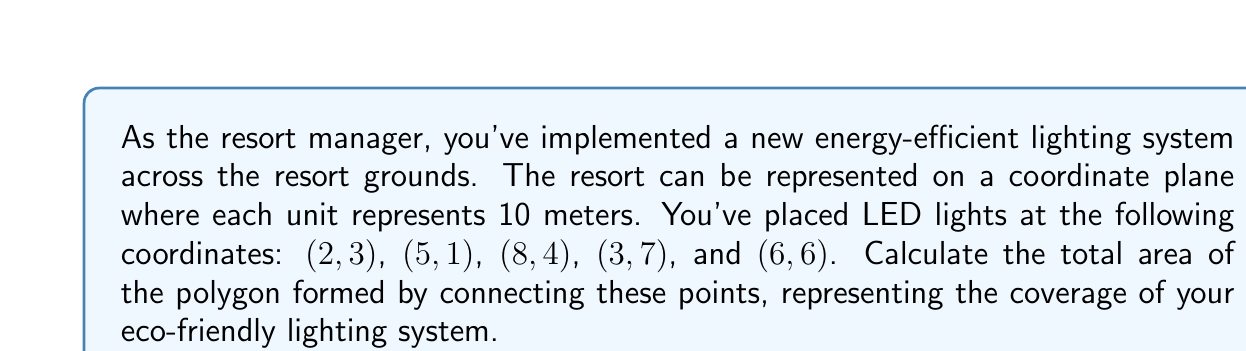What is the answer to this math problem? To solve this problem, we can use the Shoelace formula (also known as the surveyor's formula) to calculate the area of an irregular polygon given its vertices.

The Shoelace formula is:

$$A = \frac{1}{2}|\sum_{i=1}^{n-1} (x_iy_{i+1} + x_ny_1) - \sum_{i=1}^{n-1} (y_ix_{i+1} + y_nx_1)|$$

Where $(x_i, y_i)$ are the coordinates of the $i$-th vertex.

Let's organize our points:
1. (2, 3)
2. (5, 1)
3. (8, 4)
4. (3, 7)
5. (6, 6)

Now, let's apply the formula:

$$\begin{align*}
A &= \frac{1}{2}|(2 \cdot 1 + 5 \cdot 4 + 8 \cdot 7 + 3 \cdot 6 + 6 \cdot 3) - (3 \cdot 5 + 1 \cdot 8 + 4 \cdot 3 + 7 \cdot 6 + 6 \cdot 2)|\\
&= \frac{1}{2}|(2 + 20 + 56 + 18 + 18) - (15 + 8 + 12 + 42 + 12)|\\
&= \frac{1}{2}|114 - 89|\\
&= \frac{1}{2} \cdot 25\\
&= 12.5
\end{align*}$$

Therefore, the area of the polygon is 12.5 square units.

Since each unit represents 10 meters, we need to convert this to real-world measurements:

$12.5 \cdot (10 \text{ m})^2 = 12.5 \cdot 100 \text{ m}^2 = 1,250 \text{ m}^2$
Answer: The total area covered by the energy-efficient lighting system is 1,250 square meters. 